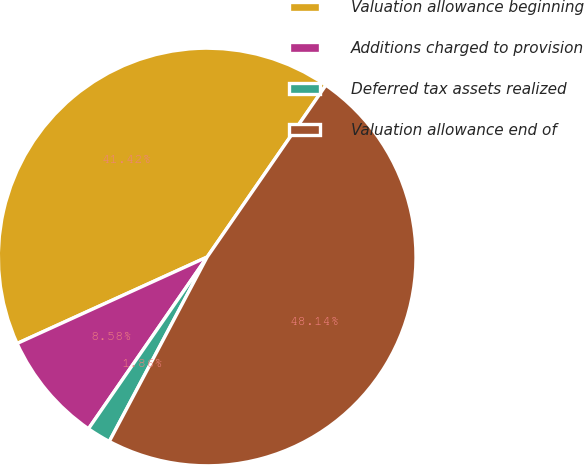Convert chart to OTSL. <chart><loc_0><loc_0><loc_500><loc_500><pie_chart><fcel>Valuation allowance beginning<fcel>Additions charged to provision<fcel>Deferred tax assets realized<fcel>Valuation allowance end of<nl><fcel>41.42%<fcel>8.58%<fcel>1.86%<fcel>48.14%<nl></chart> 